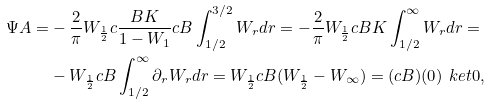Convert formula to latex. <formula><loc_0><loc_0><loc_500><loc_500>\Psi A = & - \frac { 2 } { \pi } W _ { \frac { 1 } { 2 } } c \frac { B K } { 1 - W _ { 1 } } c B \int _ { 1 / 2 } ^ { 3 / 2 } W _ { r } d r = - \frac { 2 } { \pi } W _ { \frac { 1 } { 2 } } c B K \int _ { 1 / 2 } ^ { \infty } W _ { r } d r = \\ & - W _ { \frac { 1 } { 2 } } c B \int _ { 1 / 2 } ^ { \infty } \partial _ { r } W _ { r } d r = W _ { \frac { 1 } { 2 } } c B ( W _ { \frac { 1 } { 2 } } - W _ { \infty } ) = ( c B ) ( 0 ) \ k e t { 0 } ,</formula> 